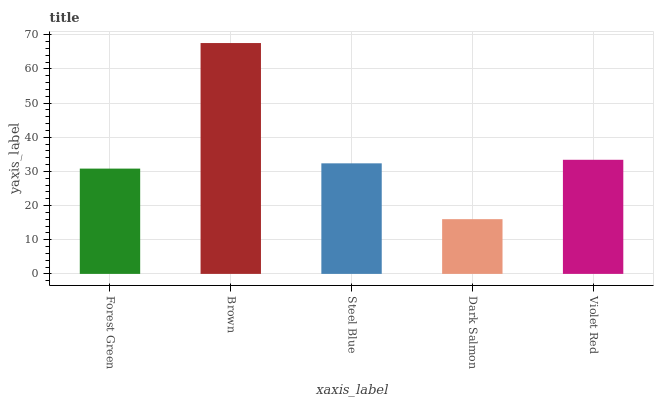Is Dark Salmon the minimum?
Answer yes or no. Yes. Is Brown the maximum?
Answer yes or no. Yes. Is Steel Blue the minimum?
Answer yes or no. No. Is Steel Blue the maximum?
Answer yes or no. No. Is Brown greater than Steel Blue?
Answer yes or no. Yes. Is Steel Blue less than Brown?
Answer yes or no. Yes. Is Steel Blue greater than Brown?
Answer yes or no. No. Is Brown less than Steel Blue?
Answer yes or no. No. Is Steel Blue the high median?
Answer yes or no. Yes. Is Steel Blue the low median?
Answer yes or no. Yes. Is Brown the high median?
Answer yes or no. No. Is Forest Green the low median?
Answer yes or no. No. 